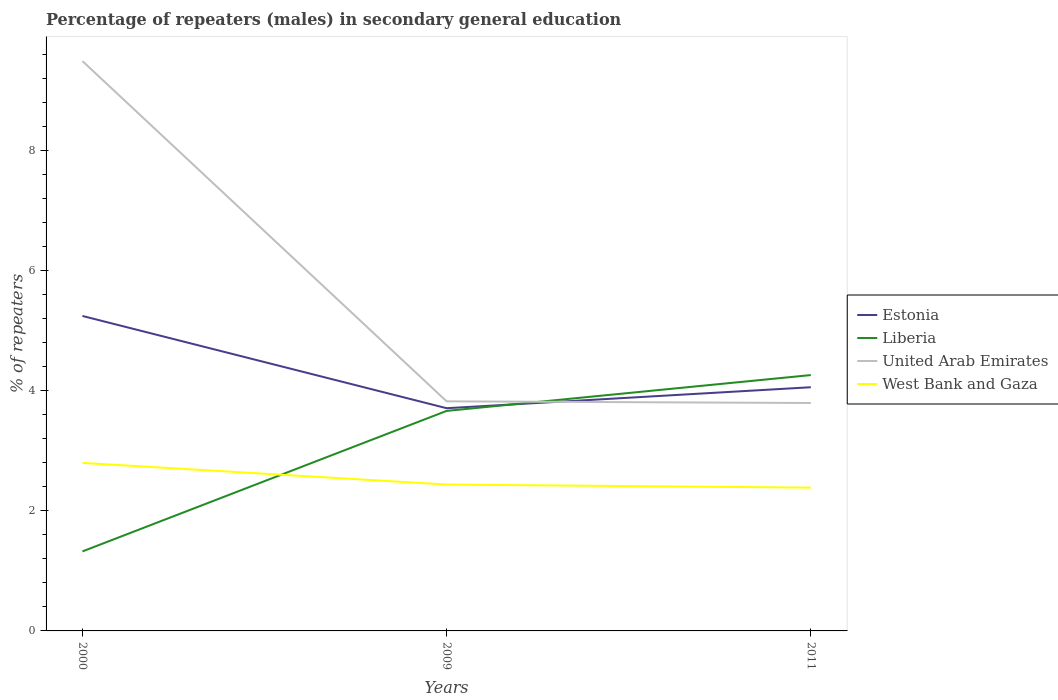Is the number of lines equal to the number of legend labels?
Provide a succinct answer. Yes. Across all years, what is the maximum percentage of male repeaters in United Arab Emirates?
Offer a very short reply. 3.8. What is the total percentage of male repeaters in West Bank and Gaza in the graph?
Provide a short and direct response. 0.05. What is the difference between the highest and the second highest percentage of male repeaters in United Arab Emirates?
Your response must be concise. 5.7. What is the difference between the highest and the lowest percentage of male repeaters in United Arab Emirates?
Your answer should be compact. 1. Are the values on the major ticks of Y-axis written in scientific E-notation?
Your answer should be very brief. No. Does the graph contain any zero values?
Make the answer very short. No. How are the legend labels stacked?
Make the answer very short. Vertical. What is the title of the graph?
Offer a terse response. Percentage of repeaters (males) in secondary general education. Does "Norway" appear as one of the legend labels in the graph?
Ensure brevity in your answer.  No. What is the label or title of the Y-axis?
Keep it short and to the point. % of repeaters. What is the % of repeaters in Estonia in 2000?
Provide a succinct answer. 5.25. What is the % of repeaters in Liberia in 2000?
Your answer should be very brief. 1.33. What is the % of repeaters of United Arab Emirates in 2000?
Ensure brevity in your answer.  9.5. What is the % of repeaters of West Bank and Gaza in 2000?
Ensure brevity in your answer.  2.8. What is the % of repeaters of Estonia in 2009?
Your answer should be compact. 3.71. What is the % of repeaters of Liberia in 2009?
Offer a very short reply. 3.67. What is the % of repeaters of United Arab Emirates in 2009?
Make the answer very short. 3.83. What is the % of repeaters of West Bank and Gaza in 2009?
Make the answer very short. 2.44. What is the % of repeaters of Estonia in 2011?
Give a very brief answer. 4.06. What is the % of repeaters of Liberia in 2011?
Keep it short and to the point. 4.26. What is the % of repeaters in United Arab Emirates in 2011?
Provide a short and direct response. 3.8. What is the % of repeaters of West Bank and Gaza in 2011?
Your response must be concise. 2.39. Across all years, what is the maximum % of repeaters in Estonia?
Your answer should be very brief. 5.25. Across all years, what is the maximum % of repeaters in Liberia?
Offer a very short reply. 4.26. Across all years, what is the maximum % of repeaters in United Arab Emirates?
Offer a terse response. 9.5. Across all years, what is the maximum % of repeaters of West Bank and Gaza?
Your answer should be very brief. 2.8. Across all years, what is the minimum % of repeaters in Estonia?
Offer a very short reply. 3.71. Across all years, what is the minimum % of repeaters of Liberia?
Your answer should be compact. 1.33. Across all years, what is the minimum % of repeaters of United Arab Emirates?
Make the answer very short. 3.8. Across all years, what is the minimum % of repeaters in West Bank and Gaza?
Give a very brief answer. 2.39. What is the total % of repeaters in Estonia in the graph?
Provide a succinct answer. 13.02. What is the total % of repeaters in Liberia in the graph?
Ensure brevity in your answer.  9.26. What is the total % of repeaters of United Arab Emirates in the graph?
Provide a short and direct response. 17.12. What is the total % of repeaters of West Bank and Gaza in the graph?
Make the answer very short. 7.63. What is the difference between the % of repeaters of Estonia in 2000 and that in 2009?
Offer a terse response. 1.54. What is the difference between the % of repeaters in Liberia in 2000 and that in 2009?
Keep it short and to the point. -2.34. What is the difference between the % of repeaters of United Arab Emirates in 2000 and that in 2009?
Ensure brevity in your answer.  5.67. What is the difference between the % of repeaters of West Bank and Gaza in 2000 and that in 2009?
Make the answer very short. 0.36. What is the difference between the % of repeaters in Estonia in 2000 and that in 2011?
Provide a succinct answer. 1.19. What is the difference between the % of repeaters of Liberia in 2000 and that in 2011?
Offer a terse response. -2.94. What is the difference between the % of repeaters of United Arab Emirates in 2000 and that in 2011?
Your response must be concise. 5.7. What is the difference between the % of repeaters of West Bank and Gaza in 2000 and that in 2011?
Your response must be concise. 0.41. What is the difference between the % of repeaters in Estonia in 2009 and that in 2011?
Your answer should be compact. -0.35. What is the difference between the % of repeaters of Liberia in 2009 and that in 2011?
Provide a short and direct response. -0.6. What is the difference between the % of repeaters of United Arab Emirates in 2009 and that in 2011?
Your answer should be very brief. 0.03. What is the difference between the % of repeaters of West Bank and Gaza in 2009 and that in 2011?
Your answer should be compact. 0.05. What is the difference between the % of repeaters in Estonia in 2000 and the % of repeaters in Liberia in 2009?
Give a very brief answer. 1.58. What is the difference between the % of repeaters in Estonia in 2000 and the % of repeaters in United Arab Emirates in 2009?
Make the answer very short. 1.42. What is the difference between the % of repeaters of Estonia in 2000 and the % of repeaters of West Bank and Gaza in 2009?
Your answer should be compact. 2.81. What is the difference between the % of repeaters of Liberia in 2000 and the % of repeaters of United Arab Emirates in 2009?
Your response must be concise. -2.5. What is the difference between the % of repeaters in Liberia in 2000 and the % of repeaters in West Bank and Gaza in 2009?
Your response must be concise. -1.11. What is the difference between the % of repeaters of United Arab Emirates in 2000 and the % of repeaters of West Bank and Gaza in 2009?
Offer a very short reply. 7.06. What is the difference between the % of repeaters in Estonia in 2000 and the % of repeaters in United Arab Emirates in 2011?
Give a very brief answer. 1.45. What is the difference between the % of repeaters of Estonia in 2000 and the % of repeaters of West Bank and Gaza in 2011?
Ensure brevity in your answer.  2.86. What is the difference between the % of repeaters of Liberia in 2000 and the % of repeaters of United Arab Emirates in 2011?
Give a very brief answer. -2.47. What is the difference between the % of repeaters of Liberia in 2000 and the % of repeaters of West Bank and Gaza in 2011?
Your answer should be very brief. -1.06. What is the difference between the % of repeaters in United Arab Emirates in 2000 and the % of repeaters in West Bank and Gaza in 2011?
Offer a terse response. 7.11. What is the difference between the % of repeaters in Estonia in 2009 and the % of repeaters in Liberia in 2011?
Your answer should be compact. -0.55. What is the difference between the % of repeaters in Estonia in 2009 and the % of repeaters in United Arab Emirates in 2011?
Provide a succinct answer. -0.09. What is the difference between the % of repeaters of Estonia in 2009 and the % of repeaters of West Bank and Gaza in 2011?
Offer a terse response. 1.32. What is the difference between the % of repeaters in Liberia in 2009 and the % of repeaters in United Arab Emirates in 2011?
Your response must be concise. -0.13. What is the difference between the % of repeaters in Liberia in 2009 and the % of repeaters in West Bank and Gaza in 2011?
Your answer should be compact. 1.28. What is the difference between the % of repeaters in United Arab Emirates in 2009 and the % of repeaters in West Bank and Gaza in 2011?
Make the answer very short. 1.44. What is the average % of repeaters of Estonia per year?
Offer a very short reply. 4.34. What is the average % of repeaters of Liberia per year?
Provide a short and direct response. 3.08. What is the average % of repeaters in United Arab Emirates per year?
Provide a short and direct response. 5.71. What is the average % of repeaters in West Bank and Gaza per year?
Ensure brevity in your answer.  2.54. In the year 2000, what is the difference between the % of repeaters in Estonia and % of repeaters in Liberia?
Keep it short and to the point. 3.92. In the year 2000, what is the difference between the % of repeaters in Estonia and % of repeaters in United Arab Emirates?
Offer a very short reply. -4.25. In the year 2000, what is the difference between the % of repeaters in Estonia and % of repeaters in West Bank and Gaza?
Ensure brevity in your answer.  2.45. In the year 2000, what is the difference between the % of repeaters of Liberia and % of repeaters of United Arab Emirates?
Provide a short and direct response. -8.17. In the year 2000, what is the difference between the % of repeaters of Liberia and % of repeaters of West Bank and Gaza?
Provide a succinct answer. -1.47. In the year 2000, what is the difference between the % of repeaters in United Arab Emirates and % of repeaters in West Bank and Gaza?
Offer a very short reply. 6.7. In the year 2009, what is the difference between the % of repeaters in Estonia and % of repeaters in Liberia?
Ensure brevity in your answer.  0.04. In the year 2009, what is the difference between the % of repeaters in Estonia and % of repeaters in United Arab Emirates?
Make the answer very short. -0.11. In the year 2009, what is the difference between the % of repeaters in Estonia and % of repeaters in West Bank and Gaza?
Provide a succinct answer. 1.27. In the year 2009, what is the difference between the % of repeaters in Liberia and % of repeaters in United Arab Emirates?
Make the answer very short. -0.16. In the year 2009, what is the difference between the % of repeaters of Liberia and % of repeaters of West Bank and Gaza?
Your answer should be very brief. 1.23. In the year 2009, what is the difference between the % of repeaters in United Arab Emirates and % of repeaters in West Bank and Gaza?
Your answer should be very brief. 1.39. In the year 2011, what is the difference between the % of repeaters in Estonia and % of repeaters in Liberia?
Give a very brief answer. -0.2. In the year 2011, what is the difference between the % of repeaters of Estonia and % of repeaters of United Arab Emirates?
Make the answer very short. 0.26. In the year 2011, what is the difference between the % of repeaters of Estonia and % of repeaters of West Bank and Gaza?
Ensure brevity in your answer.  1.67. In the year 2011, what is the difference between the % of repeaters of Liberia and % of repeaters of United Arab Emirates?
Your answer should be very brief. 0.47. In the year 2011, what is the difference between the % of repeaters of Liberia and % of repeaters of West Bank and Gaza?
Your answer should be compact. 1.88. In the year 2011, what is the difference between the % of repeaters in United Arab Emirates and % of repeaters in West Bank and Gaza?
Offer a very short reply. 1.41. What is the ratio of the % of repeaters of Estonia in 2000 to that in 2009?
Your answer should be compact. 1.41. What is the ratio of the % of repeaters in Liberia in 2000 to that in 2009?
Give a very brief answer. 0.36. What is the ratio of the % of repeaters of United Arab Emirates in 2000 to that in 2009?
Give a very brief answer. 2.48. What is the ratio of the % of repeaters of West Bank and Gaza in 2000 to that in 2009?
Offer a very short reply. 1.15. What is the ratio of the % of repeaters of Estonia in 2000 to that in 2011?
Your response must be concise. 1.29. What is the ratio of the % of repeaters in Liberia in 2000 to that in 2011?
Provide a succinct answer. 0.31. What is the ratio of the % of repeaters of United Arab Emirates in 2000 to that in 2011?
Provide a succinct answer. 2.5. What is the ratio of the % of repeaters in West Bank and Gaza in 2000 to that in 2011?
Your answer should be compact. 1.17. What is the ratio of the % of repeaters in Estonia in 2009 to that in 2011?
Provide a short and direct response. 0.91. What is the ratio of the % of repeaters of Liberia in 2009 to that in 2011?
Provide a succinct answer. 0.86. What is the ratio of the % of repeaters of United Arab Emirates in 2009 to that in 2011?
Provide a short and direct response. 1.01. What is the ratio of the % of repeaters in West Bank and Gaza in 2009 to that in 2011?
Give a very brief answer. 1.02. What is the difference between the highest and the second highest % of repeaters of Estonia?
Make the answer very short. 1.19. What is the difference between the highest and the second highest % of repeaters of Liberia?
Provide a short and direct response. 0.6. What is the difference between the highest and the second highest % of repeaters of United Arab Emirates?
Ensure brevity in your answer.  5.67. What is the difference between the highest and the second highest % of repeaters in West Bank and Gaza?
Your answer should be compact. 0.36. What is the difference between the highest and the lowest % of repeaters in Estonia?
Offer a terse response. 1.54. What is the difference between the highest and the lowest % of repeaters of Liberia?
Make the answer very short. 2.94. What is the difference between the highest and the lowest % of repeaters in United Arab Emirates?
Provide a short and direct response. 5.7. What is the difference between the highest and the lowest % of repeaters in West Bank and Gaza?
Your response must be concise. 0.41. 